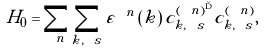<formula> <loc_0><loc_0><loc_500><loc_500>H _ { 0 } = \sum _ { \ n } \sum _ { { k } , \ s } \varepsilon ^ { \ n } \left ( { k } \right ) c ^ { ( \ n ) ^ { \dag } } _ { { k } , \ s } c ^ { ( \ n ) } _ { { k } , \ s } ,</formula> 